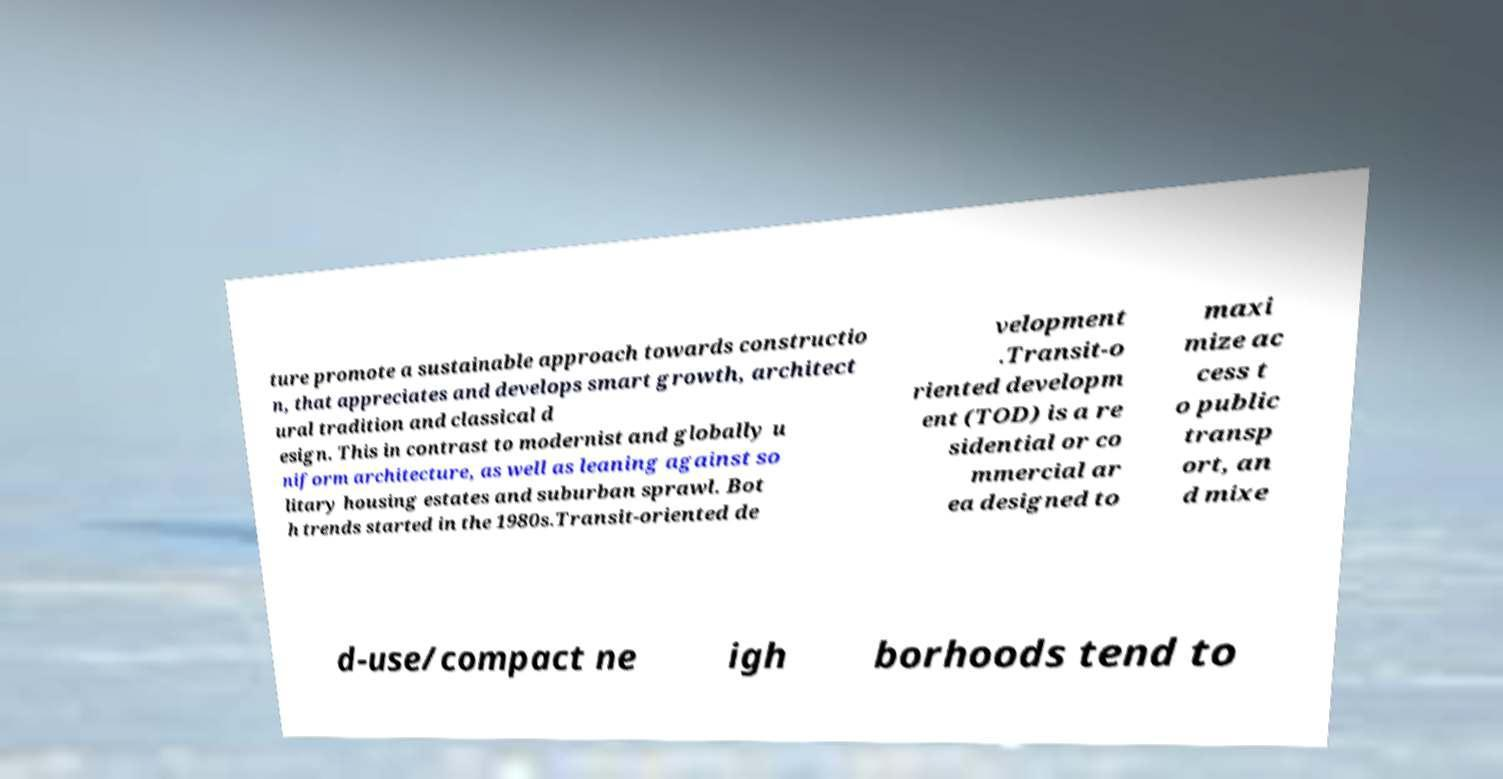I need the written content from this picture converted into text. Can you do that? ture promote a sustainable approach towards constructio n, that appreciates and develops smart growth, architect ural tradition and classical d esign. This in contrast to modernist and globally u niform architecture, as well as leaning against so litary housing estates and suburban sprawl. Bot h trends started in the 1980s.Transit-oriented de velopment .Transit-o riented developm ent (TOD) is a re sidential or co mmercial ar ea designed to maxi mize ac cess t o public transp ort, an d mixe d-use/compact ne igh borhoods tend to 